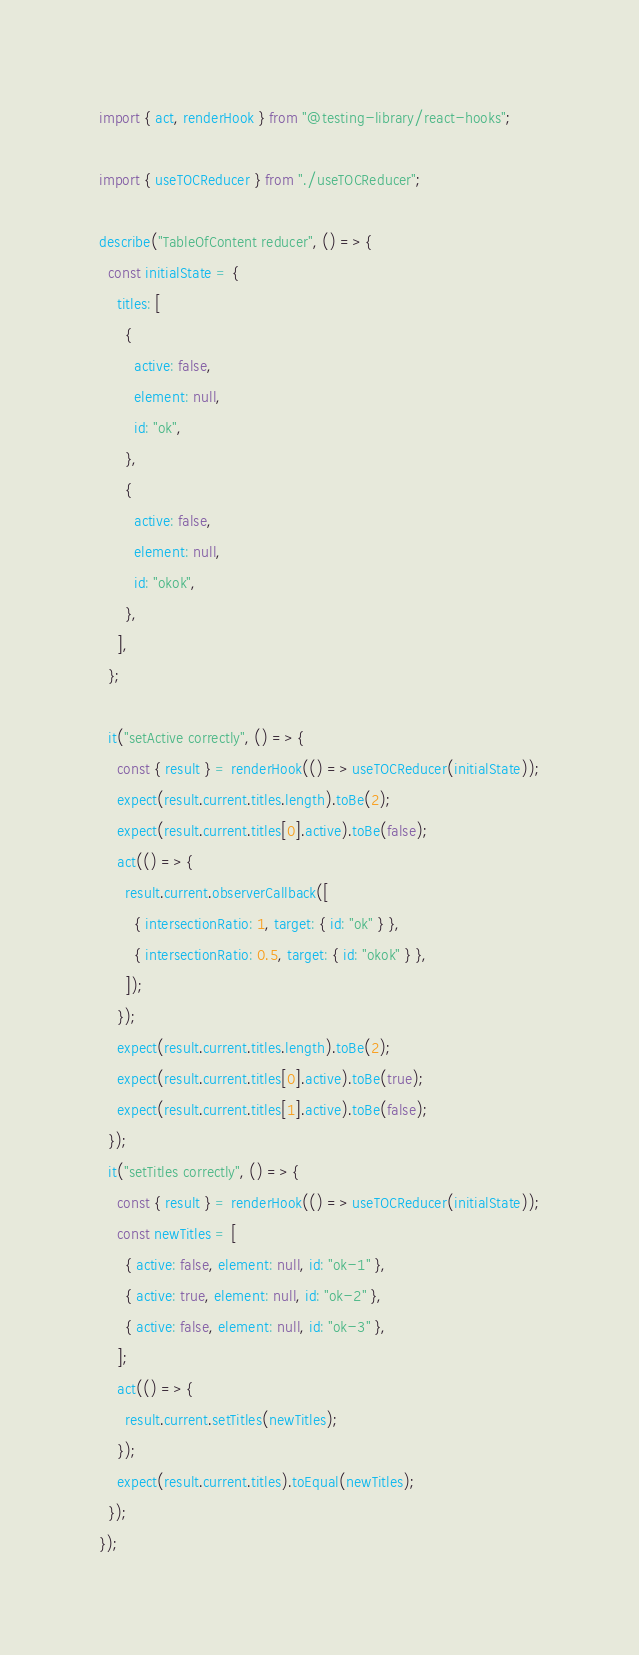<code> <loc_0><loc_0><loc_500><loc_500><_JavaScript_>import { act, renderHook } from "@testing-library/react-hooks";

import { useTOCReducer } from "./useTOCReducer";

describe("TableOfContent reducer", () => {
  const initialState = {
    titles: [
      {
        active: false,
        element: null,
        id: "ok",
      },
      {
        active: false,
        element: null,
        id: "okok",
      },
    ],
  };

  it("setActive correctly", () => {
    const { result } = renderHook(() => useTOCReducer(initialState));
    expect(result.current.titles.length).toBe(2);
    expect(result.current.titles[0].active).toBe(false);
    act(() => {
      result.current.observerCallback([
        { intersectionRatio: 1, target: { id: "ok" } },
        { intersectionRatio: 0.5, target: { id: "okok" } },
      ]);
    });
    expect(result.current.titles.length).toBe(2);
    expect(result.current.titles[0].active).toBe(true);
    expect(result.current.titles[1].active).toBe(false);
  });
  it("setTitles correctly", () => {
    const { result } = renderHook(() => useTOCReducer(initialState));
    const newTitles = [
      { active: false, element: null, id: "ok-1" },
      { active: true, element: null, id: "ok-2" },
      { active: false, element: null, id: "ok-3" },
    ];
    act(() => {
      result.current.setTitles(newTitles);
    });
    expect(result.current.titles).toEqual(newTitles);
  });
});
</code> 